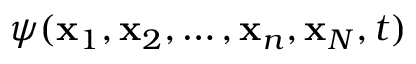Convert formula to latex. <formula><loc_0><loc_0><loc_500><loc_500>\psi ( x _ { 1 } , x _ { 2 } , \dots , x _ { n } , x _ { N } , t )</formula> 